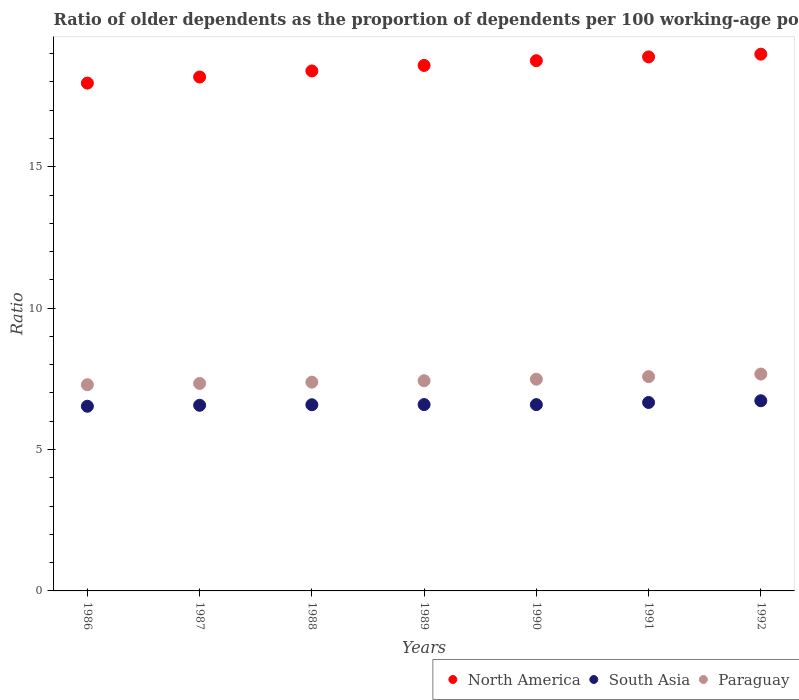How many different coloured dotlines are there?
Your answer should be compact. 3. Is the number of dotlines equal to the number of legend labels?
Keep it short and to the point. Yes. What is the age dependency ratio(old) in South Asia in 1987?
Your answer should be very brief. 6.56. Across all years, what is the maximum age dependency ratio(old) in Paraguay?
Your answer should be very brief. 7.67. Across all years, what is the minimum age dependency ratio(old) in North America?
Your response must be concise. 17.96. In which year was the age dependency ratio(old) in South Asia maximum?
Give a very brief answer. 1992. In which year was the age dependency ratio(old) in South Asia minimum?
Offer a terse response. 1986. What is the total age dependency ratio(old) in South Asia in the graph?
Ensure brevity in your answer.  46.24. What is the difference between the age dependency ratio(old) in North America in 1989 and that in 1991?
Offer a terse response. -0.3. What is the difference between the age dependency ratio(old) in South Asia in 1989 and the age dependency ratio(old) in Paraguay in 1986?
Ensure brevity in your answer.  -0.7. What is the average age dependency ratio(old) in South Asia per year?
Your answer should be very brief. 6.61. In the year 1986, what is the difference between the age dependency ratio(old) in North America and age dependency ratio(old) in Paraguay?
Make the answer very short. 10.67. In how many years, is the age dependency ratio(old) in North America greater than 4?
Your answer should be compact. 7. What is the ratio of the age dependency ratio(old) in South Asia in 1986 to that in 1989?
Your answer should be compact. 0.99. Is the difference between the age dependency ratio(old) in North America in 1989 and 1990 greater than the difference between the age dependency ratio(old) in Paraguay in 1989 and 1990?
Your answer should be very brief. No. What is the difference between the highest and the second highest age dependency ratio(old) in Paraguay?
Your answer should be compact. 0.09. What is the difference between the highest and the lowest age dependency ratio(old) in Paraguay?
Your answer should be very brief. 0.38. In how many years, is the age dependency ratio(old) in North America greater than the average age dependency ratio(old) in North America taken over all years?
Your response must be concise. 4. Is it the case that in every year, the sum of the age dependency ratio(old) in South Asia and age dependency ratio(old) in North America  is greater than the age dependency ratio(old) in Paraguay?
Your answer should be compact. Yes. Does the age dependency ratio(old) in South Asia monotonically increase over the years?
Offer a very short reply. No. How many dotlines are there?
Provide a short and direct response. 3. How many years are there in the graph?
Give a very brief answer. 7. What is the difference between two consecutive major ticks on the Y-axis?
Your answer should be very brief. 5. Does the graph contain any zero values?
Give a very brief answer. No. Where does the legend appear in the graph?
Give a very brief answer. Bottom right. How many legend labels are there?
Offer a terse response. 3. What is the title of the graph?
Your answer should be very brief. Ratio of older dependents as the proportion of dependents per 100 working-age population. Does "Haiti" appear as one of the legend labels in the graph?
Provide a short and direct response. No. What is the label or title of the X-axis?
Ensure brevity in your answer.  Years. What is the label or title of the Y-axis?
Provide a succinct answer. Ratio. What is the Ratio in North America in 1986?
Make the answer very short. 17.96. What is the Ratio of South Asia in 1986?
Ensure brevity in your answer.  6.53. What is the Ratio of Paraguay in 1986?
Provide a short and direct response. 7.29. What is the Ratio of North America in 1987?
Ensure brevity in your answer.  18.17. What is the Ratio of South Asia in 1987?
Keep it short and to the point. 6.56. What is the Ratio of Paraguay in 1987?
Offer a terse response. 7.34. What is the Ratio of North America in 1988?
Offer a very short reply. 18.39. What is the Ratio in South Asia in 1988?
Keep it short and to the point. 6.58. What is the Ratio of Paraguay in 1988?
Make the answer very short. 7.38. What is the Ratio in North America in 1989?
Make the answer very short. 18.58. What is the Ratio of South Asia in 1989?
Your response must be concise. 6.59. What is the Ratio in Paraguay in 1989?
Provide a short and direct response. 7.43. What is the Ratio in North America in 1990?
Make the answer very short. 18.75. What is the Ratio of South Asia in 1990?
Your answer should be very brief. 6.59. What is the Ratio of Paraguay in 1990?
Make the answer very short. 7.49. What is the Ratio in North America in 1991?
Provide a short and direct response. 18.88. What is the Ratio in South Asia in 1991?
Give a very brief answer. 6.66. What is the Ratio in Paraguay in 1991?
Your answer should be very brief. 7.58. What is the Ratio in North America in 1992?
Provide a short and direct response. 18.98. What is the Ratio in South Asia in 1992?
Your response must be concise. 6.72. What is the Ratio of Paraguay in 1992?
Your answer should be compact. 7.67. Across all years, what is the maximum Ratio in North America?
Ensure brevity in your answer.  18.98. Across all years, what is the maximum Ratio of South Asia?
Make the answer very short. 6.72. Across all years, what is the maximum Ratio in Paraguay?
Your answer should be compact. 7.67. Across all years, what is the minimum Ratio of North America?
Your answer should be compact. 17.96. Across all years, what is the minimum Ratio in South Asia?
Your answer should be very brief. 6.53. Across all years, what is the minimum Ratio of Paraguay?
Your answer should be compact. 7.29. What is the total Ratio of North America in the graph?
Offer a terse response. 129.71. What is the total Ratio of South Asia in the graph?
Your answer should be very brief. 46.24. What is the total Ratio in Paraguay in the graph?
Your answer should be very brief. 52.18. What is the difference between the Ratio of North America in 1986 and that in 1987?
Offer a very short reply. -0.22. What is the difference between the Ratio in South Asia in 1986 and that in 1987?
Make the answer very short. -0.03. What is the difference between the Ratio in Paraguay in 1986 and that in 1987?
Ensure brevity in your answer.  -0.05. What is the difference between the Ratio in North America in 1986 and that in 1988?
Make the answer very short. -0.43. What is the difference between the Ratio of South Asia in 1986 and that in 1988?
Your answer should be very brief. -0.05. What is the difference between the Ratio in Paraguay in 1986 and that in 1988?
Make the answer very short. -0.09. What is the difference between the Ratio in North America in 1986 and that in 1989?
Ensure brevity in your answer.  -0.62. What is the difference between the Ratio of South Asia in 1986 and that in 1989?
Keep it short and to the point. -0.06. What is the difference between the Ratio in Paraguay in 1986 and that in 1989?
Provide a short and direct response. -0.14. What is the difference between the Ratio in North America in 1986 and that in 1990?
Give a very brief answer. -0.79. What is the difference between the Ratio in South Asia in 1986 and that in 1990?
Your response must be concise. -0.06. What is the difference between the Ratio in Paraguay in 1986 and that in 1990?
Provide a short and direct response. -0.2. What is the difference between the Ratio of North America in 1986 and that in 1991?
Provide a succinct answer. -0.93. What is the difference between the Ratio in South Asia in 1986 and that in 1991?
Your response must be concise. -0.13. What is the difference between the Ratio of Paraguay in 1986 and that in 1991?
Provide a short and direct response. -0.29. What is the difference between the Ratio of North America in 1986 and that in 1992?
Offer a terse response. -1.02. What is the difference between the Ratio of South Asia in 1986 and that in 1992?
Provide a short and direct response. -0.19. What is the difference between the Ratio of Paraguay in 1986 and that in 1992?
Ensure brevity in your answer.  -0.38. What is the difference between the Ratio of North America in 1987 and that in 1988?
Give a very brief answer. -0.21. What is the difference between the Ratio of South Asia in 1987 and that in 1988?
Your response must be concise. -0.02. What is the difference between the Ratio in Paraguay in 1987 and that in 1988?
Give a very brief answer. -0.05. What is the difference between the Ratio in North America in 1987 and that in 1989?
Keep it short and to the point. -0.41. What is the difference between the Ratio in South Asia in 1987 and that in 1989?
Provide a succinct answer. -0.03. What is the difference between the Ratio of Paraguay in 1987 and that in 1989?
Offer a terse response. -0.1. What is the difference between the Ratio in North America in 1987 and that in 1990?
Offer a terse response. -0.58. What is the difference between the Ratio in South Asia in 1987 and that in 1990?
Your answer should be compact. -0.02. What is the difference between the Ratio of Paraguay in 1987 and that in 1990?
Give a very brief answer. -0.15. What is the difference between the Ratio of North America in 1987 and that in 1991?
Your response must be concise. -0.71. What is the difference between the Ratio of South Asia in 1987 and that in 1991?
Your answer should be compact. -0.1. What is the difference between the Ratio in Paraguay in 1987 and that in 1991?
Your response must be concise. -0.24. What is the difference between the Ratio in North America in 1987 and that in 1992?
Provide a succinct answer. -0.81. What is the difference between the Ratio in South Asia in 1987 and that in 1992?
Your response must be concise. -0.16. What is the difference between the Ratio of Paraguay in 1987 and that in 1992?
Give a very brief answer. -0.33. What is the difference between the Ratio of North America in 1988 and that in 1989?
Your response must be concise. -0.19. What is the difference between the Ratio in South Asia in 1988 and that in 1989?
Make the answer very short. -0.01. What is the difference between the Ratio of Paraguay in 1988 and that in 1989?
Offer a terse response. -0.05. What is the difference between the Ratio in North America in 1988 and that in 1990?
Your answer should be compact. -0.36. What is the difference between the Ratio in South Asia in 1988 and that in 1990?
Provide a succinct answer. -0.01. What is the difference between the Ratio in Paraguay in 1988 and that in 1990?
Make the answer very short. -0.1. What is the difference between the Ratio in North America in 1988 and that in 1991?
Your response must be concise. -0.5. What is the difference between the Ratio of South Asia in 1988 and that in 1991?
Make the answer very short. -0.08. What is the difference between the Ratio in Paraguay in 1988 and that in 1991?
Offer a terse response. -0.2. What is the difference between the Ratio in North America in 1988 and that in 1992?
Your answer should be very brief. -0.59. What is the difference between the Ratio of South Asia in 1988 and that in 1992?
Make the answer very short. -0.14. What is the difference between the Ratio in Paraguay in 1988 and that in 1992?
Make the answer very short. -0.29. What is the difference between the Ratio in North America in 1989 and that in 1990?
Offer a very short reply. -0.17. What is the difference between the Ratio of South Asia in 1989 and that in 1990?
Offer a very short reply. 0. What is the difference between the Ratio of Paraguay in 1989 and that in 1990?
Your response must be concise. -0.05. What is the difference between the Ratio of North America in 1989 and that in 1991?
Your answer should be very brief. -0.3. What is the difference between the Ratio in South Asia in 1989 and that in 1991?
Give a very brief answer. -0.07. What is the difference between the Ratio of Paraguay in 1989 and that in 1991?
Your response must be concise. -0.15. What is the difference between the Ratio of North America in 1989 and that in 1992?
Give a very brief answer. -0.4. What is the difference between the Ratio in South Asia in 1989 and that in 1992?
Keep it short and to the point. -0.14. What is the difference between the Ratio of Paraguay in 1989 and that in 1992?
Offer a terse response. -0.24. What is the difference between the Ratio in North America in 1990 and that in 1991?
Your answer should be very brief. -0.13. What is the difference between the Ratio in South Asia in 1990 and that in 1991?
Your answer should be compact. -0.08. What is the difference between the Ratio of Paraguay in 1990 and that in 1991?
Keep it short and to the point. -0.09. What is the difference between the Ratio in North America in 1990 and that in 1992?
Your response must be concise. -0.23. What is the difference between the Ratio of South Asia in 1990 and that in 1992?
Your answer should be very brief. -0.14. What is the difference between the Ratio in Paraguay in 1990 and that in 1992?
Your answer should be very brief. -0.18. What is the difference between the Ratio of North America in 1991 and that in 1992?
Give a very brief answer. -0.1. What is the difference between the Ratio in South Asia in 1991 and that in 1992?
Offer a very short reply. -0.06. What is the difference between the Ratio of Paraguay in 1991 and that in 1992?
Provide a succinct answer. -0.09. What is the difference between the Ratio in North America in 1986 and the Ratio in South Asia in 1987?
Keep it short and to the point. 11.39. What is the difference between the Ratio in North America in 1986 and the Ratio in Paraguay in 1987?
Ensure brevity in your answer.  10.62. What is the difference between the Ratio of South Asia in 1986 and the Ratio of Paraguay in 1987?
Your response must be concise. -0.81. What is the difference between the Ratio in North America in 1986 and the Ratio in South Asia in 1988?
Your response must be concise. 11.37. What is the difference between the Ratio in North America in 1986 and the Ratio in Paraguay in 1988?
Make the answer very short. 10.57. What is the difference between the Ratio in South Asia in 1986 and the Ratio in Paraguay in 1988?
Offer a terse response. -0.85. What is the difference between the Ratio of North America in 1986 and the Ratio of South Asia in 1989?
Your response must be concise. 11.37. What is the difference between the Ratio of North America in 1986 and the Ratio of Paraguay in 1989?
Make the answer very short. 10.52. What is the difference between the Ratio in South Asia in 1986 and the Ratio in Paraguay in 1989?
Provide a short and direct response. -0.9. What is the difference between the Ratio of North America in 1986 and the Ratio of South Asia in 1990?
Provide a short and direct response. 11.37. What is the difference between the Ratio of North America in 1986 and the Ratio of Paraguay in 1990?
Ensure brevity in your answer.  10.47. What is the difference between the Ratio of South Asia in 1986 and the Ratio of Paraguay in 1990?
Keep it short and to the point. -0.96. What is the difference between the Ratio of North America in 1986 and the Ratio of South Asia in 1991?
Provide a succinct answer. 11.29. What is the difference between the Ratio of North America in 1986 and the Ratio of Paraguay in 1991?
Offer a very short reply. 10.38. What is the difference between the Ratio of South Asia in 1986 and the Ratio of Paraguay in 1991?
Make the answer very short. -1.05. What is the difference between the Ratio in North America in 1986 and the Ratio in South Asia in 1992?
Your answer should be very brief. 11.23. What is the difference between the Ratio of North America in 1986 and the Ratio of Paraguay in 1992?
Your answer should be very brief. 10.29. What is the difference between the Ratio in South Asia in 1986 and the Ratio in Paraguay in 1992?
Offer a very short reply. -1.14. What is the difference between the Ratio of North America in 1987 and the Ratio of South Asia in 1988?
Give a very brief answer. 11.59. What is the difference between the Ratio of North America in 1987 and the Ratio of Paraguay in 1988?
Keep it short and to the point. 10.79. What is the difference between the Ratio of South Asia in 1987 and the Ratio of Paraguay in 1988?
Ensure brevity in your answer.  -0.82. What is the difference between the Ratio of North America in 1987 and the Ratio of South Asia in 1989?
Your answer should be compact. 11.58. What is the difference between the Ratio in North America in 1987 and the Ratio in Paraguay in 1989?
Offer a terse response. 10.74. What is the difference between the Ratio of South Asia in 1987 and the Ratio of Paraguay in 1989?
Make the answer very short. -0.87. What is the difference between the Ratio in North America in 1987 and the Ratio in South Asia in 1990?
Your answer should be very brief. 11.59. What is the difference between the Ratio in North America in 1987 and the Ratio in Paraguay in 1990?
Provide a short and direct response. 10.69. What is the difference between the Ratio of South Asia in 1987 and the Ratio of Paraguay in 1990?
Offer a very short reply. -0.92. What is the difference between the Ratio in North America in 1987 and the Ratio in South Asia in 1991?
Your answer should be very brief. 11.51. What is the difference between the Ratio in North America in 1987 and the Ratio in Paraguay in 1991?
Your answer should be compact. 10.59. What is the difference between the Ratio of South Asia in 1987 and the Ratio of Paraguay in 1991?
Keep it short and to the point. -1.01. What is the difference between the Ratio in North America in 1987 and the Ratio in South Asia in 1992?
Offer a very short reply. 11.45. What is the difference between the Ratio in North America in 1987 and the Ratio in Paraguay in 1992?
Your response must be concise. 10.5. What is the difference between the Ratio in South Asia in 1987 and the Ratio in Paraguay in 1992?
Your answer should be very brief. -1.11. What is the difference between the Ratio in North America in 1988 and the Ratio in South Asia in 1989?
Offer a very short reply. 11.8. What is the difference between the Ratio in North America in 1988 and the Ratio in Paraguay in 1989?
Make the answer very short. 10.95. What is the difference between the Ratio in South Asia in 1988 and the Ratio in Paraguay in 1989?
Give a very brief answer. -0.85. What is the difference between the Ratio of North America in 1988 and the Ratio of South Asia in 1990?
Keep it short and to the point. 11.8. What is the difference between the Ratio in North America in 1988 and the Ratio in Paraguay in 1990?
Keep it short and to the point. 10.9. What is the difference between the Ratio in South Asia in 1988 and the Ratio in Paraguay in 1990?
Offer a very short reply. -0.9. What is the difference between the Ratio of North America in 1988 and the Ratio of South Asia in 1991?
Your response must be concise. 11.72. What is the difference between the Ratio of North America in 1988 and the Ratio of Paraguay in 1991?
Your answer should be compact. 10.81. What is the difference between the Ratio in South Asia in 1988 and the Ratio in Paraguay in 1991?
Your answer should be very brief. -1. What is the difference between the Ratio in North America in 1988 and the Ratio in South Asia in 1992?
Provide a succinct answer. 11.66. What is the difference between the Ratio of North America in 1988 and the Ratio of Paraguay in 1992?
Offer a terse response. 10.72. What is the difference between the Ratio in South Asia in 1988 and the Ratio in Paraguay in 1992?
Provide a succinct answer. -1.09. What is the difference between the Ratio of North America in 1989 and the Ratio of South Asia in 1990?
Make the answer very short. 11.99. What is the difference between the Ratio in North America in 1989 and the Ratio in Paraguay in 1990?
Keep it short and to the point. 11.09. What is the difference between the Ratio in South Asia in 1989 and the Ratio in Paraguay in 1990?
Give a very brief answer. -0.9. What is the difference between the Ratio in North America in 1989 and the Ratio in South Asia in 1991?
Provide a short and direct response. 11.92. What is the difference between the Ratio in North America in 1989 and the Ratio in Paraguay in 1991?
Your response must be concise. 11. What is the difference between the Ratio of South Asia in 1989 and the Ratio of Paraguay in 1991?
Your answer should be compact. -0.99. What is the difference between the Ratio in North America in 1989 and the Ratio in South Asia in 1992?
Offer a very short reply. 11.86. What is the difference between the Ratio of North America in 1989 and the Ratio of Paraguay in 1992?
Offer a terse response. 10.91. What is the difference between the Ratio in South Asia in 1989 and the Ratio in Paraguay in 1992?
Give a very brief answer. -1.08. What is the difference between the Ratio of North America in 1990 and the Ratio of South Asia in 1991?
Your answer should be compact. 12.09. What is the difference between the Ratio in North America in 1990 and the Ratio in Paraguay in 1991?
Make the answer very short. 11.17. What is the difference between the Ratio of South Asia in 1990 and the Ratio of Paraguay in 1991?
Your response must be concise. -0.99. What is the difference between the Ratio of North America in 1990 and the Ratio of South Asia in 1992?
Ensure brevity in your answer.  12.02. What is the difference between the Ratio of North America in 1990 and the Ratio of Paraguay in 1992?
Offer a very short reply. 11.08. What is the difference between the Ratio of South Asia in 1990 and the Ratio of Paraguay in 1992?
Your response must be concise. -1.08. What is the difference between the Ratio of North America in 1991 and the Ratio of South Asia in 1992?
Offer a terse response. 12.16. What is the difference between the Ratio of North America in 1991 and the Ratio of Paraguay in 1992?
Make the answer very short. 11.21. What is the difference between the Ratio of South Asia in 1991 and the Ratio of Paraguay in 1992?
Offer a very short reply. -1.01. What is the average Ratio in North America per year?
Your answer should be very brief. 18.53. What is the average Ratio in South Asia per year?
Provide a short and direct response. 6.61. What is the average Ratio in Paraguay per year?
Provide a succinct answer. 7.45. In the year 1986, what is the difference between the Ratio of North America and Ratio of South Asia?
Provide a short and direct response. 11.43. In the year 1986, what is the difference between the Ratio of North America and Ratio of Paraguay?
Your answer should be compact. 10.67. In the year 1986, what is the difference between the Ratio of South Asia and Ratio of Paraguay?
Provide a succinct answer. -0.76. In the year 1987, what is the difference between the Ratio in North America and Ratio in South Asia?
Give a very brief answer. 11.61. In the year 1987, what is the difference between the Ratio in North America and Ratio in Paraguay?
Offer a very short reply. 10.84. In the year 1987, what is the difference between the Ratio of South Asia and Ratio of Paraguay?
Make the answer very short. -0.77. In the year 1988, what is the difference between the Ratio in North America and Ratio in South Asia?
Give a very brief answer. 11.8. In the year 1988, what is the difference between the Ratio of North America and Ratio of Paraguay?
Make the answer very short. 11. In the year 1988, what is the difference between the Ratio of South Asia and Ratio of Paraguay?
Your answer should be very brief. -0.8. In the year 1989, what is the difference between the Ratio in North America and Ratio in South Asia?
Offer a very short reply. 11.99. In the year 1989, what is the difference between the Ratio in North America and Ratio in Paraguay?
Ensure brevity in your answer.  11.15. In the year 1989, what is the difference between the Ratio of South Asia and Ratio of Paraguay?
Your response must be concise. -0.84. In the year 1990, what is the difference between the Ratio of North America and Ratio of South Asia?
Your answer should be very brief. 12.16. In the year 1990, what is the difference between the Ratio in North America and Ratio in Paraguay?
Your answer should be compact. 11.26. In the year 1990, what is the difference between the Ratio of South Asia and Ratio of Paraguay?
Offer a very short reply. -0.9. In the year 1991, what is the difference between the Ratio in North America and Ratio in South Asia?
Give a very brief answer. 12.22. In the year 1991, what is the difference between the Ratio in North America and Ratio in Paraguay?
Your answer should be very brief. 11.3. In the year 1991, what is the difference between the Ratio of South Asia and Ratio of Paraguay?
Your response must be concise. -0.91. In the year 1992, what is the difference between the Ratio of North America and Ratio of South Asia?
Your answer should be very brief. 12.26. In the year 1992, what is the difference between the Ratio in North America and Ratio in Paraguay?
Your answer should be compact. 11.31. In the year 1992, what is the difference between the Ratio in South Asia and Ratio in Paraguay?
Make the answer very short. -0.94. What is the ratio of the Ratio in North America in 1986 to that in 1987?
Offer a very short reply. 0.99. What is the ratio of the Ratio in North America in 1986 to that in 1988?
Keep it short and to the point. 0.98. What is the ratio of the Ratio of South Asia in 1986 to that in 1988?
Provide a short and direct response. 0.99. What is the ratio of the Ratio of Paraguay in 1986 to that in 1988?
Make the answer very short. 0.99. What is the ratio of the Ratio of North America in 1986 to that in 1989?
Keep it short and to the point. 0.97. What is the ratio of the Ratio of South Asia in 1986 to that in 1989?
Offer a terse response. 0.99. What is the ratio of the Ratio in North America in 1986 to that in 1990?
Ensure brevity in your answer.  0.96. What is the ratio of the Ratio in South Asia in 1986 to that in 1990?
Make the answer very short. 0.99. What is the ratio of the Ratio of Paraguay in 1986 to that in 1990?
Your answer should be very brief. 0.97. What is the ratio of the Ratio of North America in 1986 to that in 1991?
Your answer should be compact. 0.95. What is the ratio of the Ratio in Paraguay in 1986 to that in 1991?
Your answer should be compact. 0.96. What is the ratio of the Ratio in North America in 1986 to that in 1992?
Offer a terse response. 0.95. What is the ratio of the Ratio in Paraguay in 1986 to that in 1992?
Keep it short and to the point. 0.95. What is the ratio of the Ratio in North America in 1987 to that in 1988?
Make the answer very short. 0.99. What is the ratio of the Ratio in South Asia in 1987 to that in 1988?
Give a very brief answer. 1. What is the ratio of the Ratio in Paraguay in 1987 to that in 1989?
Your response must be concise. 0.99. What is the ratio of the Ratio of North America in 1987 to that in 1990?
Offer a terse response. 0.97. What is the ratio of the Ratio of South Asia in 1987 to that in 1990?
Offer a very short reply. 1. What is the ratio of the Ratio of Paraguay in 1987 to that in 1990?
Your response must be concise. 0.98. What is the ratio of the Ratio in North America in 1987 to that in 1991?
Your answer should be very brief. 0.96. What is the ratio of the Ratio of South Asia in 1987 to that in 1991?
Make the answer very short. 0.99. What is the ratio of the Ratio of Paraguay in 1987 to that in 1991?
Offer a terse response. 0.97. What is the ratio of the Ratio of North America in 1987 to that in 1992?
Ensure brevity in your answer.  0.96. What is the ratio of the Ratio in South Asia in 1987 to that in 1992?
Your answer should be very brief. 0.98. What is the ratio of the Ratio in Paraguay in 1987 to that in 1992?
Provide a succinct answer. 0.96. What is the ratio of the Ratio in Paraguay in 1988 to that in 1989?
Ensure brevity in your answer.  0.99. What is the ratio of the Ratio in North America in 1988 to that in 1990?
Your response must be concise. 0.98. What is the ratio of the Ratio of South Asia in 1988 to that in 1990?
Provide a short and direct response. 1. What is the ratio of the Ratio of North America in 1988 to that in 1991?
Make the answer very short. 0.97. What is the ratio of the Ratio of South Asia in 1988 to that in 1991?
Make the answer very short. 0.99. What is the ratio of the Ratio in Paraguay in 1988 to that in 1991?
Give a very brief answer. 0.97. What is the ratio of the Ratio in North America in 1988 to that in 1992?
Offer a very short reply. 0.97. What is the ratio of the Ratio of South Asia in 1988 to that in 1992?
Give a very brief answer. 0.98. What is the ratio of the Ratio of Paraguay in 1988 to that in 1992?
Your answer should be compact. 0.96. What is the ratio of the Ratio in North America in 1989 to that in 1991?
Your answer should be very brief. 0.98. What is the ratio of the Ratio of South Asia in 1989 to that in 1991?
Offer a very short reply. 0.99. What is the ratio of the Ratio in Paraguay in 1989 to that in 1991?
Your answer should be compact. 0.98. What is the ratio of the Ratio of North America in 1989 to that in 1992?
Your response must be concise. 0.98. What is the ratio of the Ratio of South Asia in 1989 to that in 1992?
Offer a terse response. 0.98. What is the ratio of the Ratio of Paraguay in 1989 to that in 1992?
Provide a succinct answer. 0.97. What is the ratio of the Ratio in North America in 1990 to that in 1991?
Provide a succinct answer. 0.99. What is the ratio of the Ratio in Paraguay in 1990 to that in 1991?
Your response must be concise. 0.99. What is the ratio of the Ratio in South Asia in 1990 to that in 1992?
Your response must be concise. 0.98. What is the ratio of the Ratio in Paraguay in 1990 to that in 1992?
Your answer should be compact. 0.98. What is the ratio of the Ratio of South Asia in 1991 to that in 1992?
Offer a very short reply. 0.99. What is the difference between the highest and the second highest Ratio of North America?
Give a very brief answer. 0.1. What is the difference between the highest and the second highest Ratio in South Asia?
Provide a short and direct response. 0.06. What is the difference between the highest and the second highest Ratio of Paraguay?
Provide a succinct answer. 0.09. What is the difference between the highest and the lowest Ratio in North America?
Your response must be concise. 1.02. What is the difference between the highest and the lowest Ratio in South Asia?
Ensure brevity in your answer.  0.19. What is the difference between the highest and the lowest Ratio of Paraguay?
Provide a short and direct response. 0.38. 